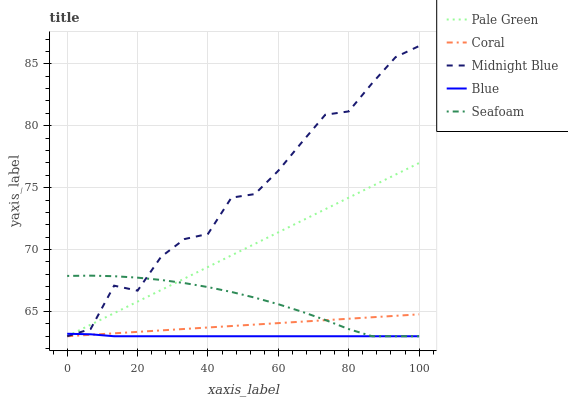Does Blue have the minimum area under the curve?
Answer yes or no. Yes. Does Midnight Blue have the maximum area under the curve?
Answer yes or no. Yes. Does Coral have the minimum area under the curve?
Answer yes or no. No. Does Coral have the maximum area under the curve?
Answer yes or no. No. Is Coral the smoothest?
Answer yes or no. Yes. Is Midnight Blue the roughest?
Answer yes or no. Yes. Is Pale Green the smoothest?
Answer yes or no. No. Is Pale Green the roughest?
Answer yes or no. No. Does Blue have the lowest value?
Answer yes or no. Yes. Does Midnight Blue have the highest value?
Answer yes or no. Yes. Does Coral have the highest value?
Answer yes or no. No. Does Midnight Blue intersect Pale Green?
Answer yes or no. Yes. Is Midnight Blue less than Pale Green?
Answer yes or no. No. Is Midnight Blue greater than Pale Green?
Answer yes or no. No. 